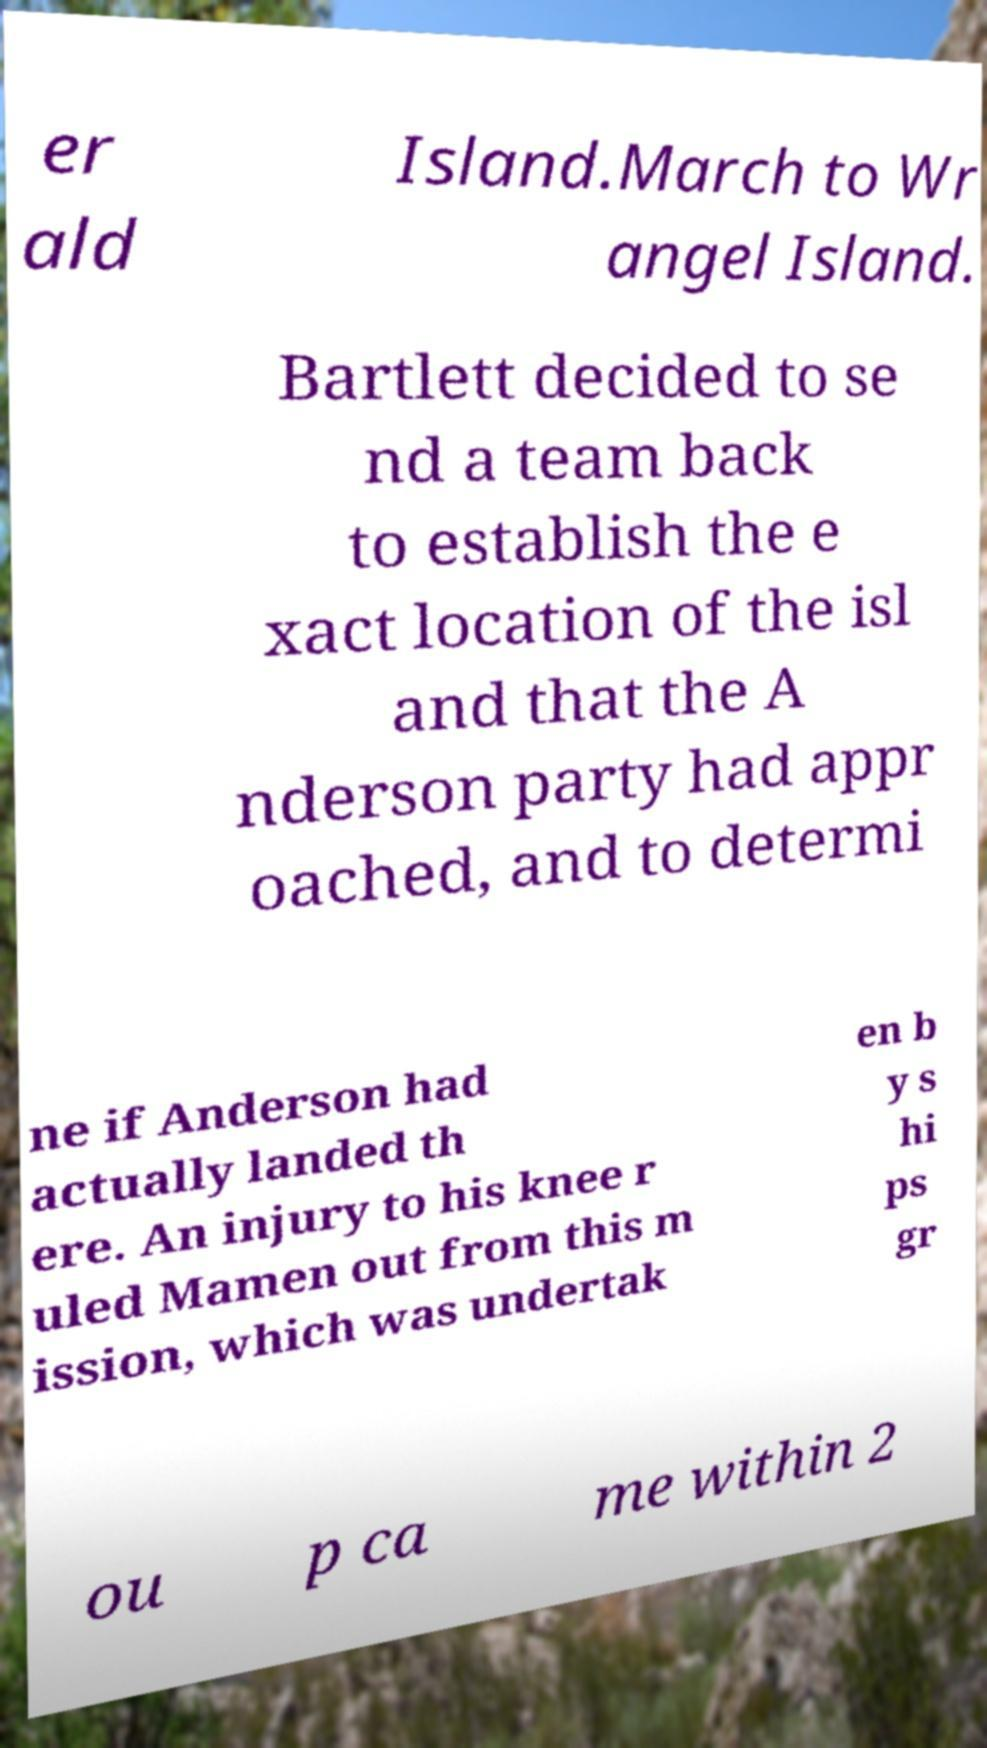Can you accurately transcribe the text from the provided image for me? er ald Island.March to Wr angel Island. Bartlett decided to se nd a team back to establish the e xact location of the isl and that the A nderson party had appr oached, and to determi ne if Anderson had actually landed th ere. An injury to his knee r uled Mamen out from this m ission, which was undertak en b y s hi ps gr ou p ca me within 2 